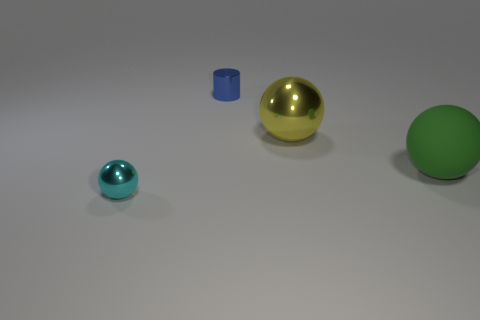Subtract all big metal spheres. How many spheres are left? 2 Add 2 large green things. How many objects exist? 6 Subtract all green spheres. How many spheres are left? 2 Subtract all spheres. How many objects are left? 1 Add 1 large green objects. How many large green objects are left? 2 Add 1 yellow metallic things. How many yellow metallic things exist? 2 Subtract 1 cyan spheres. How many objects are left? 3 Subtract all brown balls. Subtract all purple blocks. How many balls are left? 3 Subtract all brown blocks. How many red cylinders are left? 0 Subtract all big yellow metal spheres. Subtract all big green rubber balls. How many objects are left? 2 